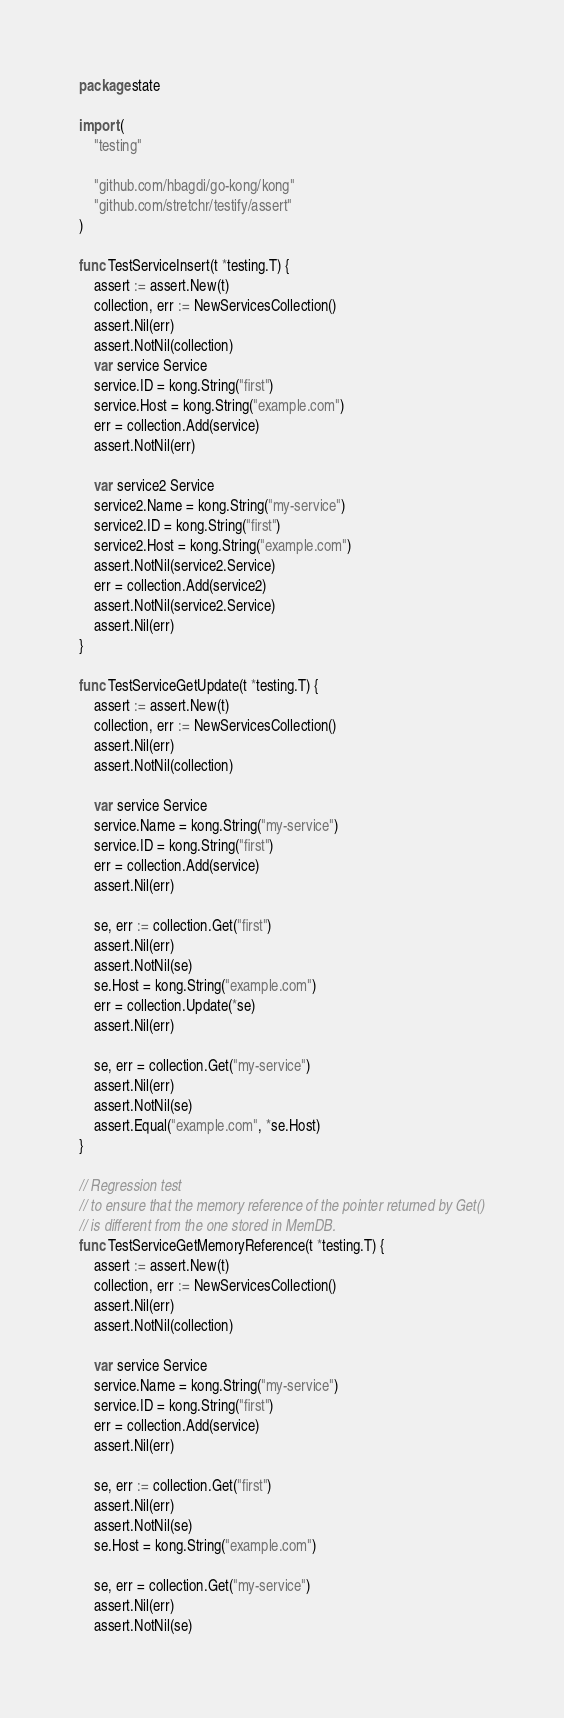<code> <loc_0><loc_0><loc_500><loc_500><_Go_>package state

import (
	"testing"

	"github.com/hbagdi/go-kong/kong"
	"github.com/stretchr/testify/assert"
)

func TestServiceInsert(t *testing.T) {
	assert := assert.New(t)
	collection, err := NewServicesCollection()
	assert.Nil(err)
	assert.NotNil(collection)
	var service Service
	service.ID = kong.String("first")
	service.Host = kong.String("example.com")
	err = collection.Add(service)
	assert.NotNil(err)

	var service2 Service
	service2.Name = kong.String("my-service")
	service2.ID = kong.String("first")
	service2.Host = kong.String("example.com")
	assert.NotNil(service2.Service)
	err = collection.Add(service2)
	assert.NotNil(service2.Service)
	assert.Nil(err)
}

func TestServiceGetUpdate(t *testing.T) {
	assert := assert.New(t)
	collection, err := NewServicesCollection()
	assert.Nil(err)
	assert.NotNil(collection)

	var service Service
	service.Name = kong.String("my-service")
	service.ID = kong.String("first")
	err = collection.Add(service)
	assert.Nil(err)

	se, err := collection.Get("first")
	assert.Nil(err)
	assert.NotNil(se)
	se.Host = kong.String("example.com")
	err = collection.Update(*se)
	assert.Nil(err)

	se, err = collection.Get("my-service")
	assert.Nil(err)
	assert.NotNil(se)
	assert.Equal("example.com", *se.Host)
}

// Regression test
// to ensure that the memory reference of the pointer returned by Get()
// is different from the one stored in MemDB.
func TestServiceGetMemoryReference(t *testing.T) {
	assert := assert.New(t)
	collection, err := NewServicesCollection()
	assert.Nil(err)
	assert.NotNil(collection)

	var service Service
	service.Name = kong.String("my-service")
	service.ID = kong.String("first")
	err = collection.Add(service)
	assert.Nil(err)

	se, err := collection.Get("first")
	assert.Nil(err)
	assert.NotNil(se)
	se.Host = kong.String("example.com")

	se, err = collection.Get("my-service")
	assert.Nil(err)
	assert.NotNil(se)</code> 